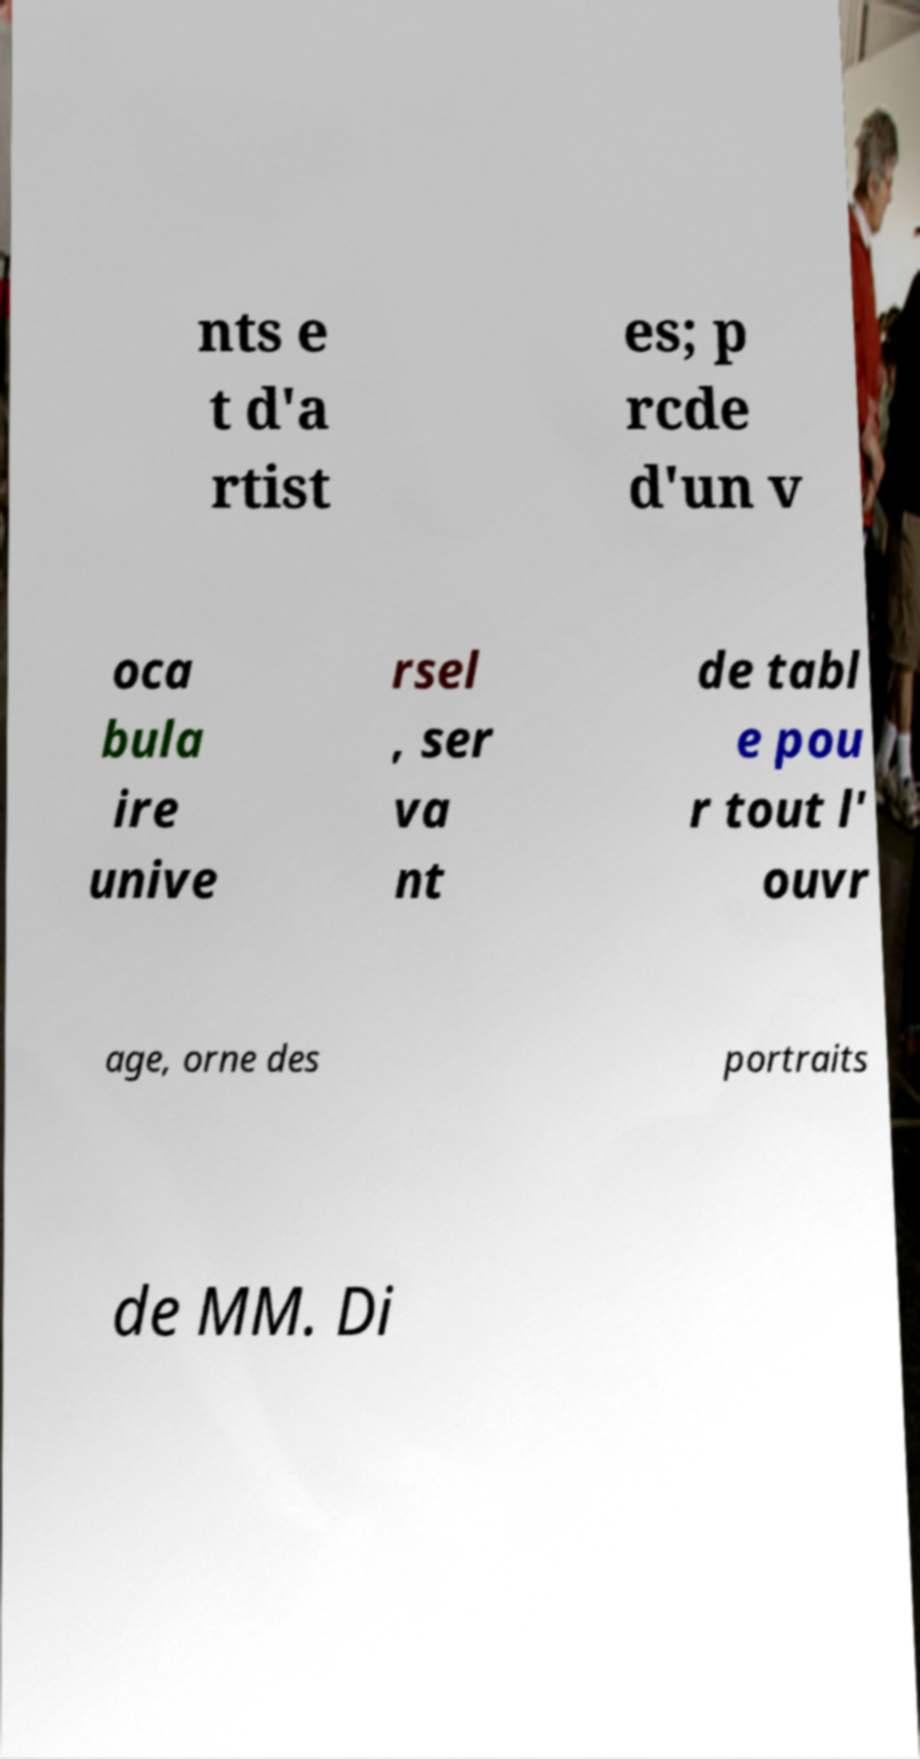Please identify and transcribe the text found in this image. nts e t d'a rtist es; p rcde d'un v oca bula ire unive rsel , ser va nt de tabl e pou r tout l' ouvr age, orne des portraits de MM. Di 